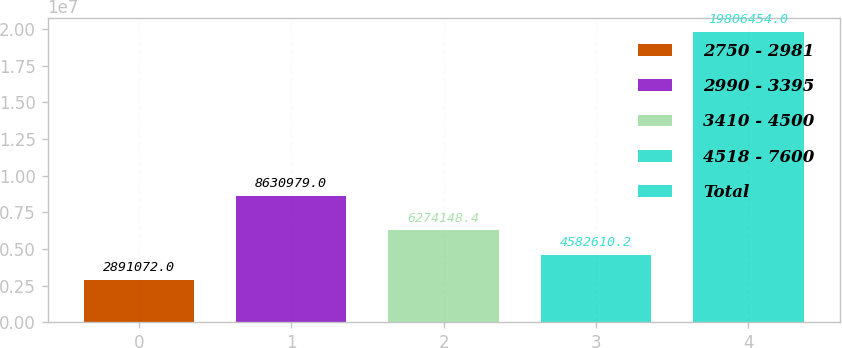<chart> <loc_0><loc_0><loc_500><loc_500><bar_chart><fcel>2750 - 2981<fcel>2990 - 3395<fcel>3410 - 4500<fcel>4518 - 7600<fcel>Total<nl><fcel>2.89107e+06<fcel>8.63098e+06<fcel>6.27415e+06<fcel>4.58261e+06<fcel>1.98065e+07<nl></chart> 